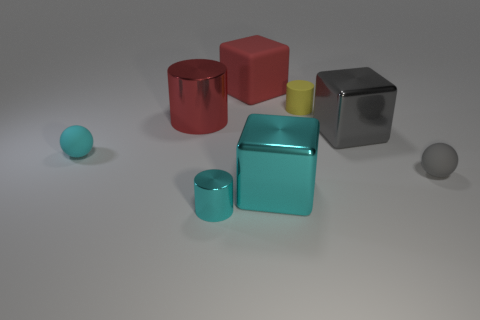There is a cyan metallic object that is left of the cyan metallic thing that is right of the rubber block; what shape is it?
Provide a succinct answer. Cylinder. What shape is the big object that is made of the same material as the tiny yellow object?
Make the answer very short. Cube. How many other objects are there of the same shape as the tiny gray rubber thing?
Ensure brevity in your answer.  1. There is a shiny cylinder that is right of the red cylinder; is its size the same as the big cyan thing?
Keep it short and to the point. No. Is the number of red things that are behind the small yellow cylinder greater than the number of yellow shiny objects?
Keep it short and to the point. Yes. There is a tiny matte ball left of the large gray object; what number of shiny objects are left of it?
Offer a very short reply. 0. Are there fewer small yellow cylinders that are on the right side of the big red matte cube than tiny rubber cylinders?
Keep it short and to the point. No. There is a large gray metallic object that is right of the cyan metallic object right of the small shiny object; are there any metal cylinders that are behind it?
Provide a succinct answer. Yes. Is the big red cylinder made of the same material as the gray object right of the large gray cube?
Offer a terse response. No. The small object to the left of the tiny cyan thing that is to the right of the large red metallic cylinder is what color?
Ensure brevity in your answer.  Cyan. 